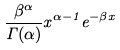<formula> <loc_0><loc_0><loc_500><loc_500>\frac { \beta ^ { \alpha } } { \Gamma ( \alpha ) } x ^ { \alpha - 1 } e ^ { - \beta x }</formula> 